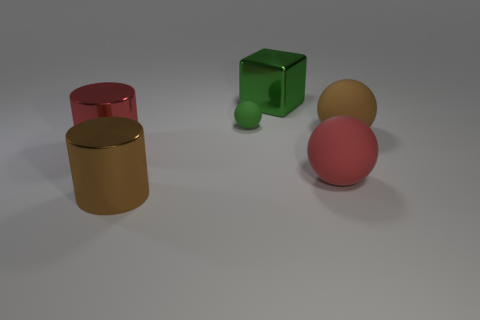There is a thing that is the same color as the big block; what is its shape?
Ensure brevity in your answer.  Sphere. What is the material of the big ball that is in front of the large rubber thing behind the red object on the left side of the metal cube?
Your answer should be very brief. Rubber. What number of objects are either brown metallic cylinders or large things that are on the left side of the green metal block?
Ensure brevity in your answer.  2. There is a metal thing that is on the right side of the large brown cylinder; is it the same color as the small matte ball?
Keep it short and to the point. Yes. Is the number of shiny things behind the small green matte ball greater than the number of green blocks that are in front of the big green cube?
Your response must be concise. Yes. Is there anything else that is the same color as the small ball?
Give a very brief answer. Yes. How many things are either big red metal things or small metal balls?
Offer a very short reply. 1. There is a object behind the green matte object; is it the same size as the tiny object?
Offer a terse response. No. What number of other things are the same size as the green sphere?
Your answer should be very brief. 0. Is there a large yellow metallic cube?
Your response must be concise. No. 